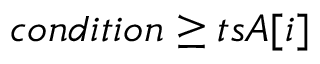Convert formula to latex. <formula><loc_0><loc_0><loc_500><loc_500>c o n d i t i o n \geq t s A [ i ]</formula> 